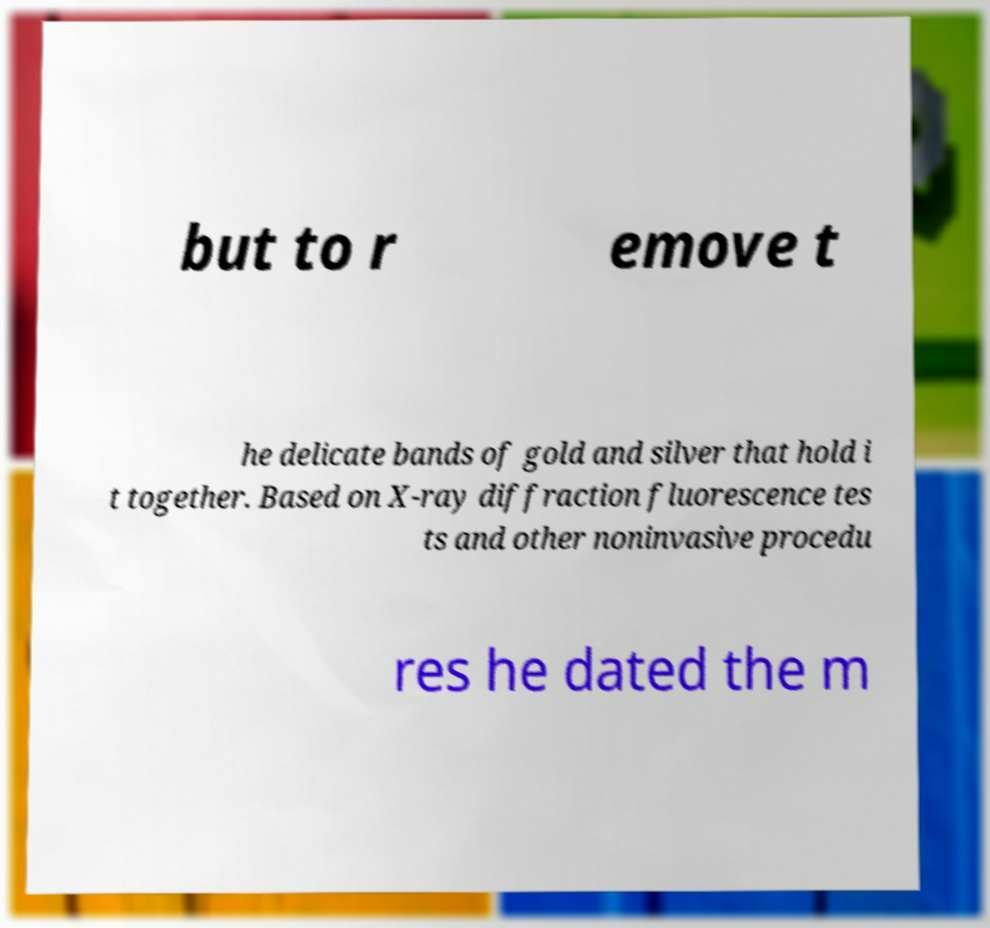Could you extract and type out the text from this image? but to r emove t he delicate bands of gold and silver that hold i t together. Based on X-ray diffraction fluorescence tes ts and other noninvasive procedu res he dated the m 